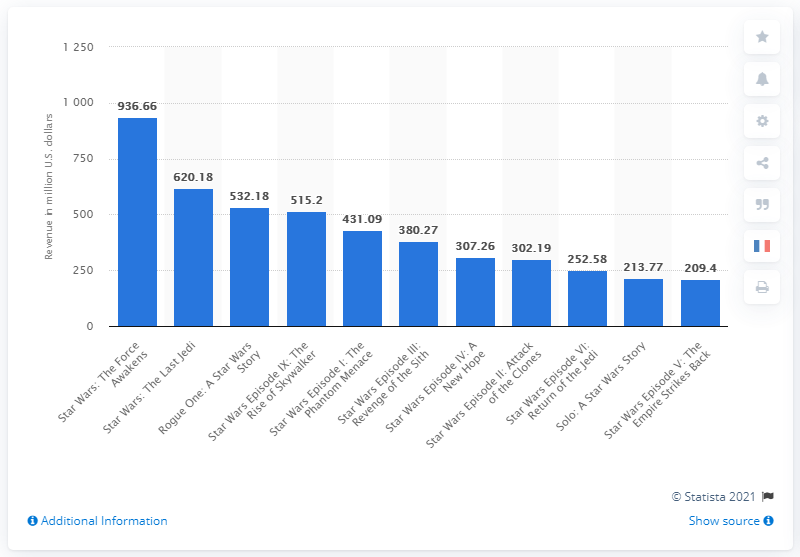Specify some key components in this picture. According to Box Office Mojo, the latest installment of the Star Wars franchise, "Star Wars Episode IX: The Rise of Skywalker," grossed an estimated $515.2 million globally. 